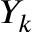Convert formula to latex. <formula><loc_0><loc_0><loc_500><loc_500>Y _ { k }</formula> 